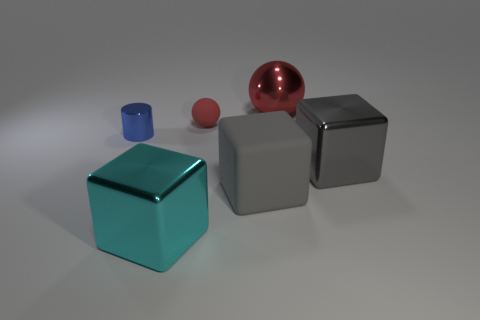How many other large balls are the same color as the rubber ball?
Give a very brief answer. 1. Are there fewer large cyan shiny cubes that are in front of the cyan thing than tiny blue metal things?
Offer a very short reply. Yes. There is a gray thing that is made of the same material as the big cyan block; what shape is it?
Provide a succinct answer. Cube. What number of matte objects are either tiny cyan balls or tiny blue cylinders?
Offer a terse response. 0. Are there an equal number of tiny blue cylinders left of the tiny shiny object and big cyan things?
Provide a short and direct response. No. Does the thing right of the big sphere have the same color as the small cylinder?
Your answer should be compact. No. What is the object that is left of the matte ball and in front of the small blue metallic object made of?
Your response must be concise. Metal. Is there a red matte thing that is to the right of the big object in front of the gray rubber object?
Ensure brevity in your answer.  Yes. Is the material of the small blue cylinder the same as the large ball?
Keep it short and to the point. Yes. There is a metallic thing that is both on the right side of the small sphere and in front of the small red sphere; what shape is it?
Ensure brevity in your answer.  Cube. 